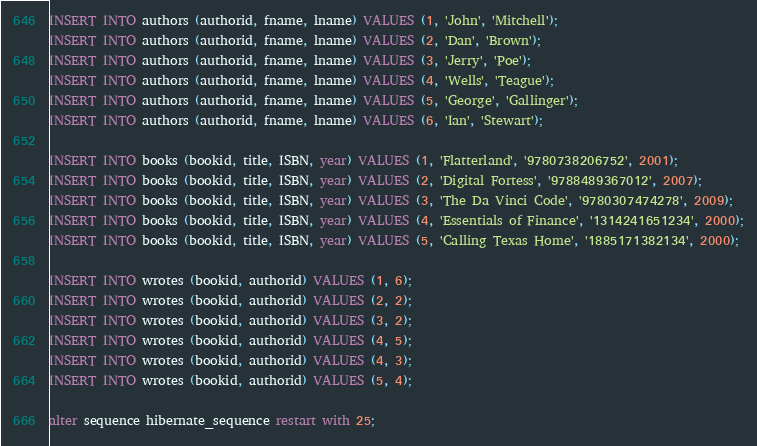Convert code to text. <code><loc_0><loc_0><loc_500><loc_500><_SQL_>INSERT INTO authors (authorid, fname, lname) VALUES (1, 'John', 'Mitchell');
INSERT INTO authors (authorid, fname, lname) VALUES (2, 'Dan', 'Brown');
INSERT INTO authors (authorid, fname, lname) VALUES (3, 'Jerry', 'Poe');
INSERT INTO authors (authorid, fname, lname) VALUES (4, 'Wells', 'Teague');
INSERT INTO authors (authorid, fname, lname) VALUES (5, 'George', 'Gallinger');
INSERT INTO authors (authorid, fname, lname) VALUES (6, 'Ian', 'Stewart');

INSERT INTO books (bookid, title, ISBN, year) VALUES (1, 'Flatterland', '9780738206752', 2001);
INSERT INTO books (bookid, title, ISBN, year) VALUES (2, 'Digital Fortess', '9788489367012', 2007);
INSERT INTO books (bookid, title, ISBN, year) VALUES (3, 'The Da Vinci Code', '9780307474278', 2009);
INSERT INTO books (bookid, title, ISBN, year) VALUES (4, 'Essentials of Finance', '1314241651234', 2000);
INSERT INTO books (bookid, title, ISBN, year) VALUES (5, 'Calling Texas Home', '1885171382134', 2000);

INSERT INTO wrotes (bookid, authorid) VALUES (1, 6);
INSERT INTO wrotes (bookid, authorid) VALUES (2, 2);
INSERT INTO wrotes (bookid, authorid) VALUES (3, 2);
INSERT INTO wrotes (bookid, authorid) VALUES (4, 5);
INSERT INTO wrotes (bookid, authorid) VALUES (4, 3);
INSERT INTO wrotes (bookid, authorid) VALUES (5, 4);

alter sequence hibernate_sequence restart with 25;
</code> 